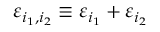Convert formula to latex. <formula><loc_0><loc_0><loc_500><loc_500>\varepsilon _ { i _ { 1 } , i _ { 2 } } \equiv \varepsilon _ { i _ { 1 } } + \varepsilon _ { i _ { 2 } }</formula> 